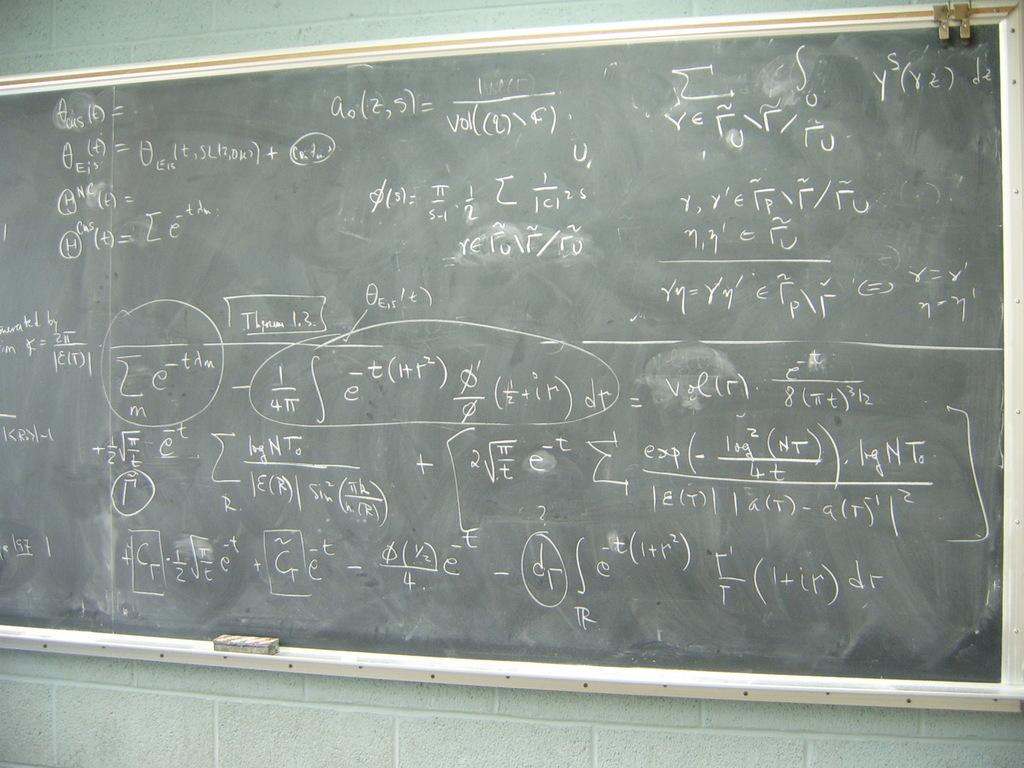<image>
Summarize the visual content of the image. A dusty dirty chalkboard where the two letters in the bottom right corner are dr. 